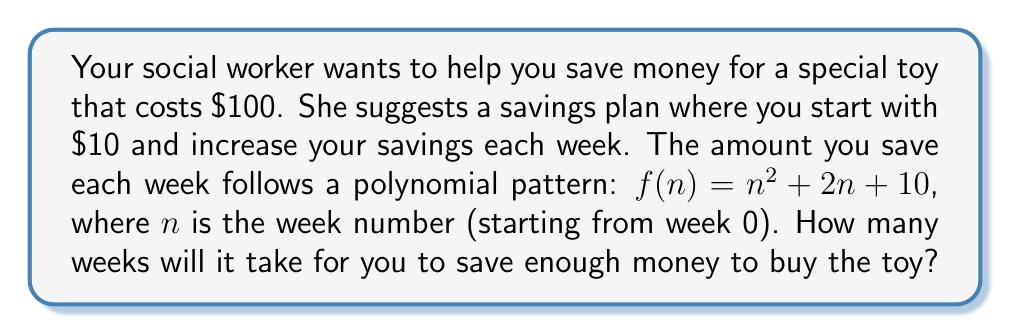Can you answer this question? Let's approach this step-by-step:

1) The savings function is $f(n) = n^2 + 2n + 10$, where $n$ is the week number.

2) We need to find the smallest value of $n$ where the sum of savings up to that week exceeds or equals $100.

3) Mathematically, we're looking for the smallest $n$ that satisfies:

   $$\sum_{i=0}^n (i^2 + 2i + 10) \geq 100$$

4) Let's calculate the savings for each week:
   Week 0: $0^2 + 2(0) + 10 = 10$
   Week 1: $1^2 + 2(1) + 10 = 13$
   Week 2: $2^2 + 2(2) + 10 = 18$
   Week 3: $3^2 + 2(3) + 10 = 25$

5) Now let's sum these up:
   After Week 0: $10$
   After Week 1: $10 + 13 = 23$
   After Week 2: $23 + 18 = 41$
   After Week 3: $41 + 25 = 66$
   After Week 4: $66 + (4^2 + 2(4) + 10) = 66 + 34 = 100$

6) We see that after Week 4, the total savings is exactly $100.

Therefore, it will take 4 weeks to save enough money for the toy.
Answer: 4 weeks 